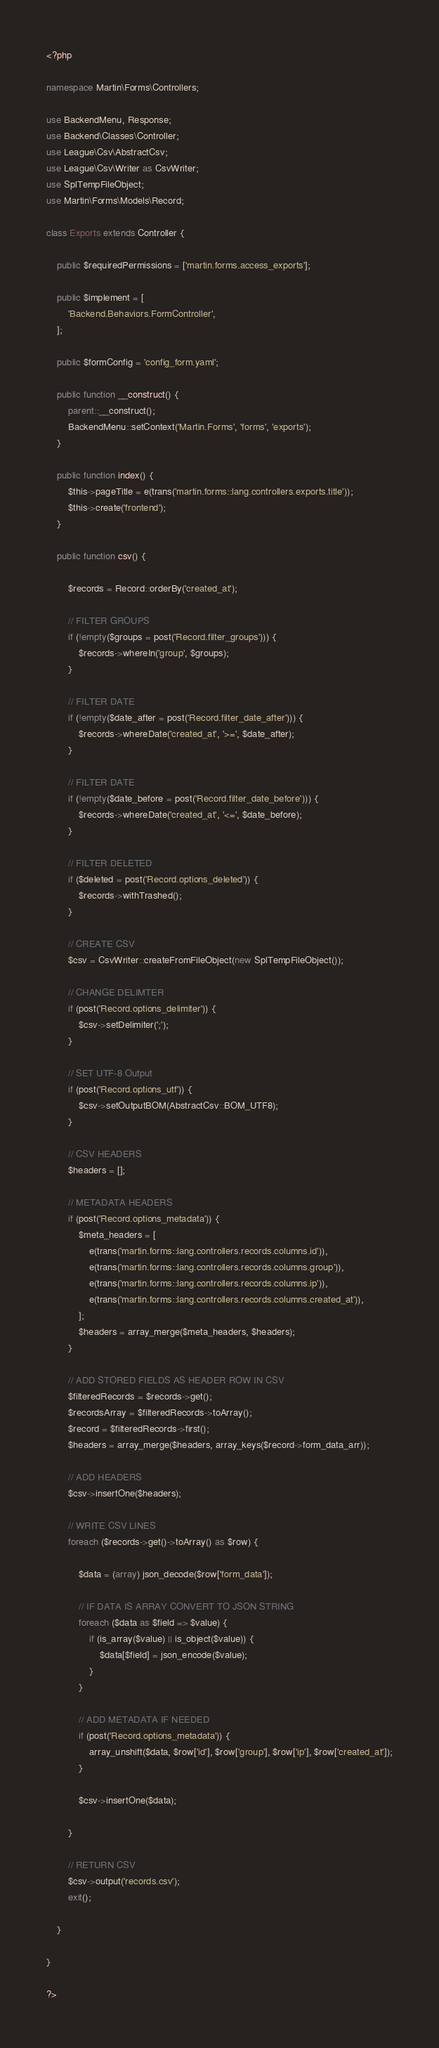<code> <loc_0><loc_0><loc_500><loc_500><_PHP_><?php

namespace Martin\Forms\Controllers;

use BackendMenu, Response;
use Backend\Classes\Controller;
use League\Csv\AbstractCsv;
use League\Csv\Writer as CsvWriter;
use SplTempFileObject;
use Martin\Forms\Models\Record;

class Exports extends Controller {

    public $requiredPermissions = ['martin.forms.access_exports'];

    public $implement = [
        'Backend.Behaviors.FormController',
    ];

    public $formConfig = 'config_form.yaml';

    public function __construct() {
        parent::__construct();
        BackendMenu::setContext('Martin.Forms', 'forms', 'exports');
    }

    public function index() {
        $this->pageTitle = e(trans('martin.forms::lang.controllers.exports.title'));
        $this->create('frontend');
    }

    public function csv() {

        $records = Record::orderBy('created_at');

        // FILTER GROUPS
        if (!empty($groups = post('Record.filter_groups'))) {
            $records->whereIn('group', $groups);
        }

        // FILTER DATE
        if (!empty($date_after = post('Record.filter_date_after'))) {
            $records->whereDate('created_at', '>=', $date_after);
        }

        // FILTER DATE
        if (!empty($date_before = post('Record.filter_date_before'))) {
            $records->whereDate('created_at', '<=', $date_before);
        }

        // FILTER DELETED
        if ($deleted = post('Record.options_deleted')) {
            $records->withTrashed();
        }

        // CREATE CSV
        $csv = CsvWriter::createFromFileObject(new SplTempFileObject());

        // CHANGE DELIMTER
        if (post('Record.options_delimiter')) {
            $csv->setDelimiter(';');
        }

        // SET UTF-8 Output
        if (post('Record.options_utf')) {
            $csv->setOutputBOM(AbstractCsv::BOM_UTF8);
        }

        // CSV HEADERS
        $headers = [];

        // METADATA HEADERS
        if (post('Record.options_metadata')) {
            $meta_headers = [
                e(trans('martin.forms::lang.controllers.records.columns.id')),
                e(trans('martin.forms::lang.controllers.records.columns.group')),
                e(trans('martin.forms::lang.controllers.records.columns.ip')),
                e(trans('martin.forms::lang.controllers.records.columns.created_at')),
            ];
            $headers = array_merge($meta_headers, $headers);
        }

        // ADD STORED FIELDS AS HEADER ROW IN CSV
        $filteredRecords = $records->get();
        $recordsArray = $filteredRecords->toArray();
        $record = $filteredRecords->first();
        $headers = array_merge($headers, array_keys($record->form_data_arr));

        // ADD HEADERS
        $csv->insertOne($headers);

        // WRITE CSV LINES
        foreach ($records->get()->toArray() as $row) {

            $data = (array) json_decode($row['form_data']);

            // IF DATA IS ARRAY CONVERT TO JSON STRING
            foreach ($data as $field => $value) {
                if (is_array($value) || is_object($value)) {
                    $data[$field] = json_encode($value);
                }
            }

            // ADD METADATA IF NEEDED
            if (post('Record.options_metadata')) {
                array_unshift($data, $row['id'], $row['group'], $row['ip'], $row['created_at']);
            }

            $csv->insertOne($data);

        }

        // RETURN CSV
        $csv->output('records.csv');
        exit();

    }

}

?>
</code> 